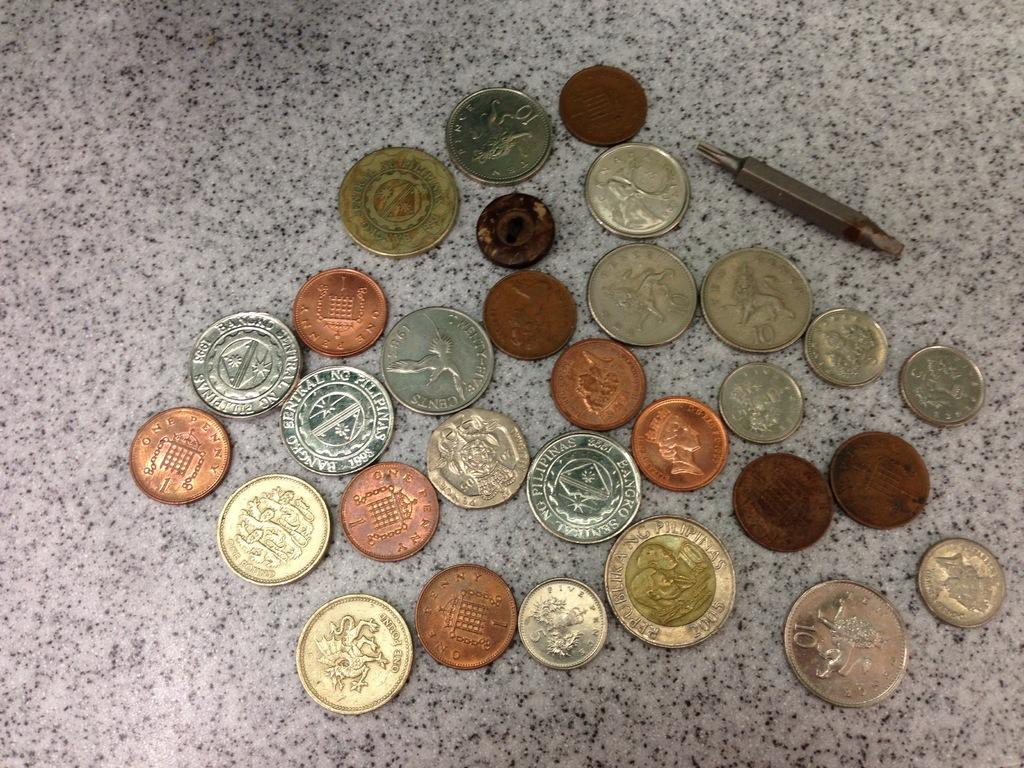<image>
Present a compact description of the photo's key features. A one pound coin with a dragon on it sits with many other coins. 